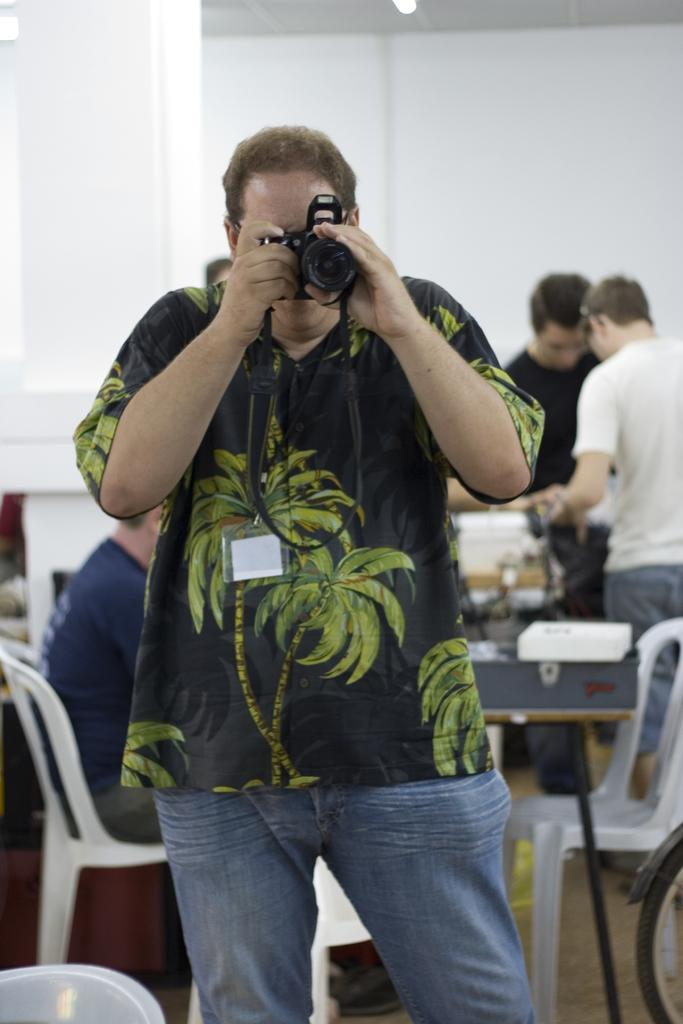What is the person in the image doing? The person is standing and holding a camera in the image. What might the person be about to do with the camera? The person might be about to take a picture with the camera. What can be seen in the background of the image? There is a table visible in the background of the image. Are there any other people present in the image? Yes, there are other persons present in the background of the image. How many kittens are sitting on the vessel in the image? There are no kittens or vessels present in the image. What direction is the person pointing the camera in the image? The facts provided do not specify the direction the person is pointing the camera. 